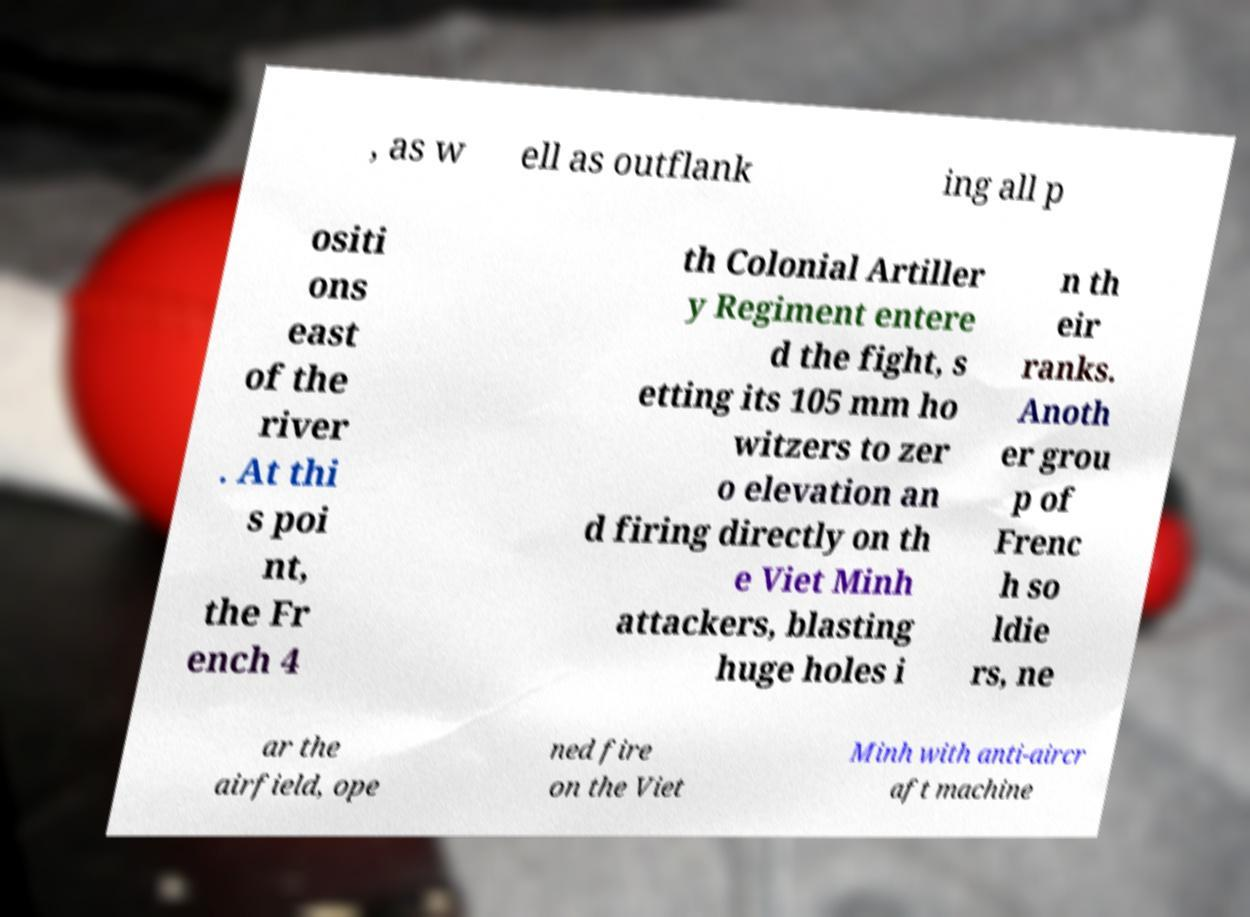There's text embedded in this image that I need extracted. Can you transcribe it verbatim? , as w ell as outflank ing all p ositi ons east of the river . At thi s poi nt, the Fr ench 4 th Colonial Artiller y Regiment entere d the fight, s etting its 105 mm ho witzers to zer o elevation an d firing directly on th e Viet Minh attackers, blasting huge holes i n th eir ranks. Anoth er grou p of Frenc h so ldie rs, ne ar the airfield, ope ned fire on the Viet Minh with anti-aircr aft machine 